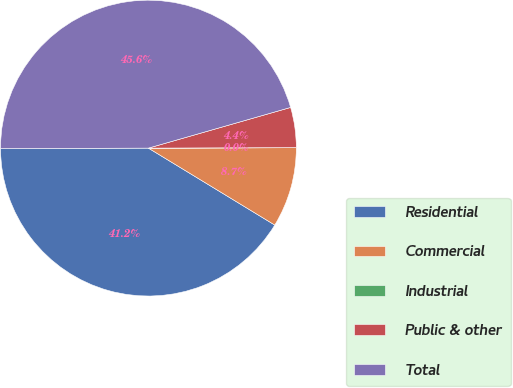Convert chart to OTSL. <chart><loc_0><loc_0><loc_500><loc_500><pie_chart><fcel>Residential<fcel>Commercial<fcel>Industrial<fcel>Public & other<fcel>Total<nl><fcel>41.25%<fcel>8.75%<fcel>0.01%<fcel>4.38%<fcel>45.62%<nl></chart> 